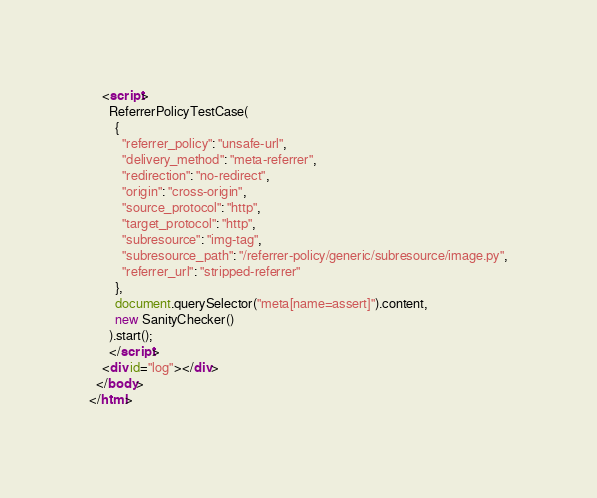Convert code to text. <code><loc_0><loc_0><loc_500><loc_500><_HTML_>    <script>
      ReferrerPolicyTestCase(
        {
          "referrer_policy": "unsafe-url",
          "delivery_method": "meta-referrer",
          "redirection": "no-redirect",
          "origin": "cross-origin",
          "source_protocol": "http",
          "target_protocol": "http",
          "subresource": "img-tag",
          "subresource_path": "/referrer-policy/generic/subresource/image.py",
          "referrer_url": "stripped-referrer"
        },
        document.querySelector("meta[name=assert]").content,
        new SanityChecker()
      ).start();
      </script>
    <div id="log"></div>
  </body>
</html>
</code> 